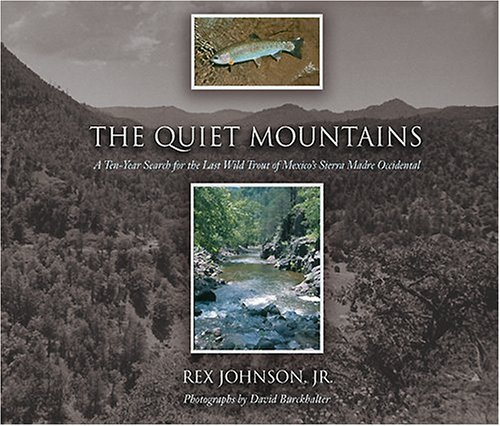Who wrote this book?
Answer the question using a single word or phrase. Rex Johnson Jr. What is the title of this book? The Quiet Mountains: A Ten-Year Search for the Last Wild Trout of Mexico's Sierra Madre Occidental (University of Arizona Southwest Centre) What type of book is this? Humor & Entertainment Is this a comedy book? Yes Is this a motivational book? No 